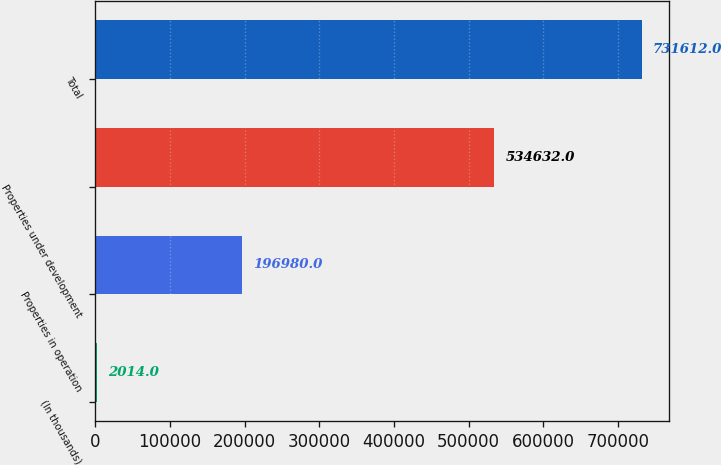Convert chart to OTSL. <chart><loc_0><loc_0><loc_500><loc_500><bar_chart><fcel>(In thousands)<fcel>Properties in operation<fcel>Properties under development<fcel>Total<nl><fcel>2014<fcel>196980<fcel>534632<fcel>731612<nl></chart> 